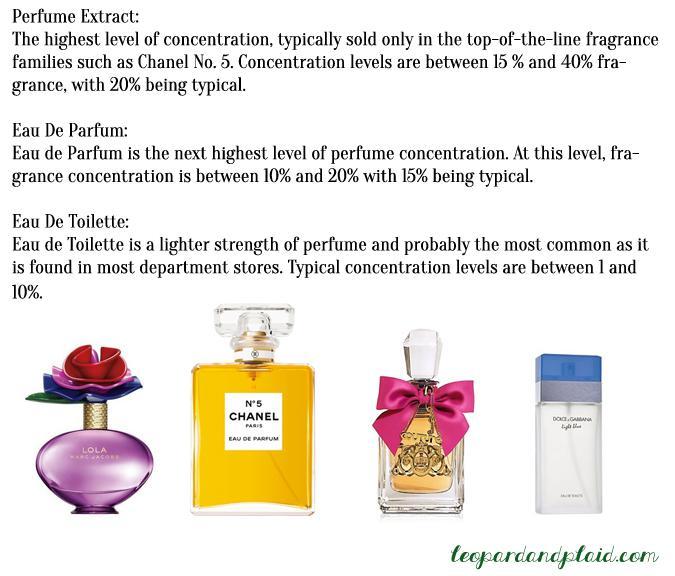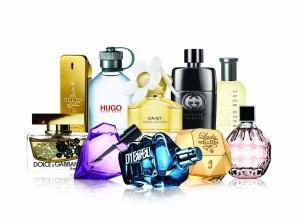The first image is the image on the left, the second image is the image on the right. Given the left and right images, does the statement "There is a single squared full chanel number 5 perfume bottle in at least one image." hold true? Answer yes or no. Yes. 